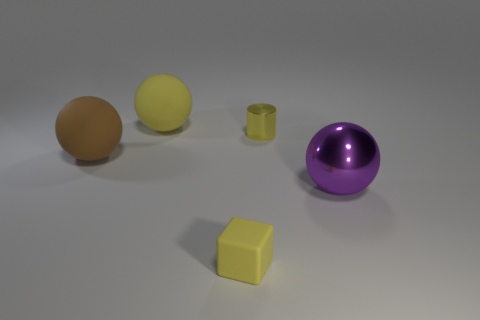Add 1 big yellow matte spheres. How many objects exist? 6 Subtract all balls. How many objects are left? 2 Subtract all big blue cylinders. Subtract all large yellow balls. How many objects are left? 4 Add 1 large metal balls. How many large metal balls are left? 2 Add 3 large brown spheres. How many large brown spheres exist? 4 Subtract 0 red cubes. How many objects are left? 5 